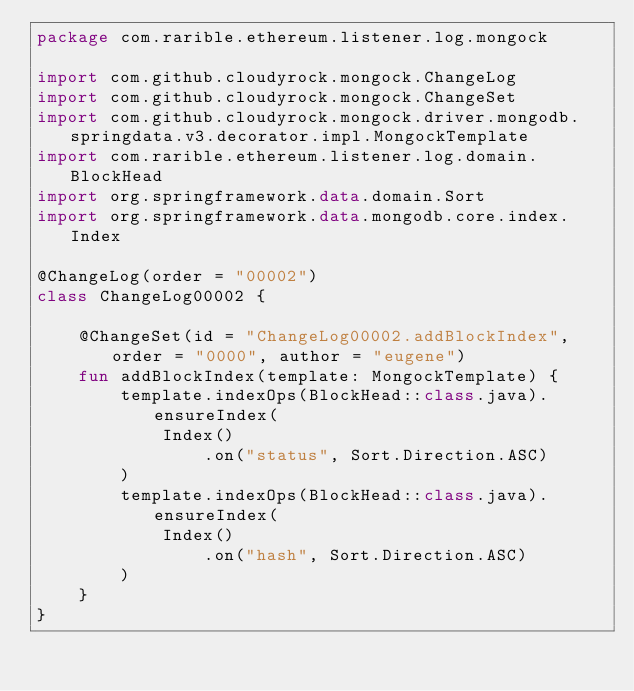Convert code to text. <code><loc_0><loc_0><loc_500><loc_500><_Kotlin_>package com.rarible.ethereum.listener.log.mongock

import com.github.cloudyrock.mongock.ChangeLog
import com.github.cloudyrock.mongock.ChangeSet
import com.github.cloudyrock.mongock.driver.mongodb.springdata.v3.decorator.impl.MongockTemplate
import com.rarible.ethereum.listener.log.domain.BlockHead
import org.springframework.data.domain.Sort
import org.springframework.data.mongodb.core.index.Index

@ChangeLog(order = "00002")
class ChangeLog00002 {

    @ChangeSet(id = "ChangeLog00002.addBlockIndex", order = "0000", author = "eugene")
    fun addBlockIndex(template: MongockTemplate) {
        template.indexOps(BlockHead::class.java).ensureIndex(
            Index()
                .on("status", Sort.Direction.ASC)
        )
        template.indexOps(BlockHead::class.java).ensureIndex(
            Index()
                .on("hash", Sort.Direction.ASC)
        )
    }
}</code> 